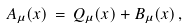<formula> <loc_0><loc_0><loc_500><loc_500>A _ { \mu } ( x ) \, = \, Q _ { \mu } ( x ) + B _ { \mu } ( x ) \, ,</formula> 